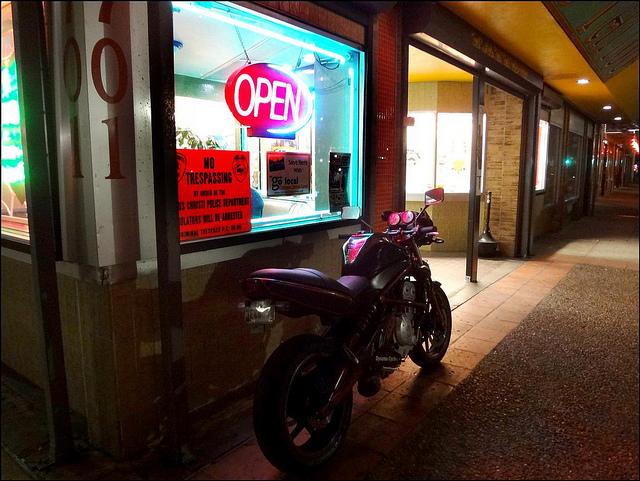Is it daytime?
Keep it brief. No. Are they closed?
Keep it brief. No. Is the motorcycle parked in a parking lot?
Concise answer only. No. 